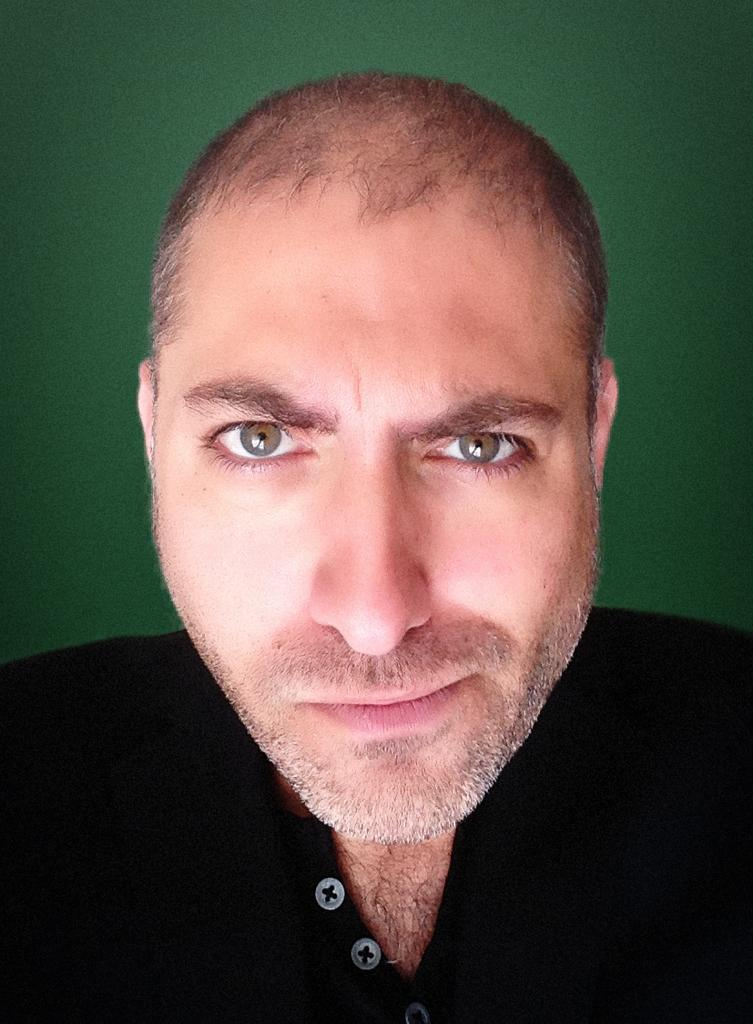Who is present in the image? There is a man in the image. What can be seen in the background of the image? The background of the image is green. What type of news is the man reading in the image? There is no indication in the image that the man is reading any news. 